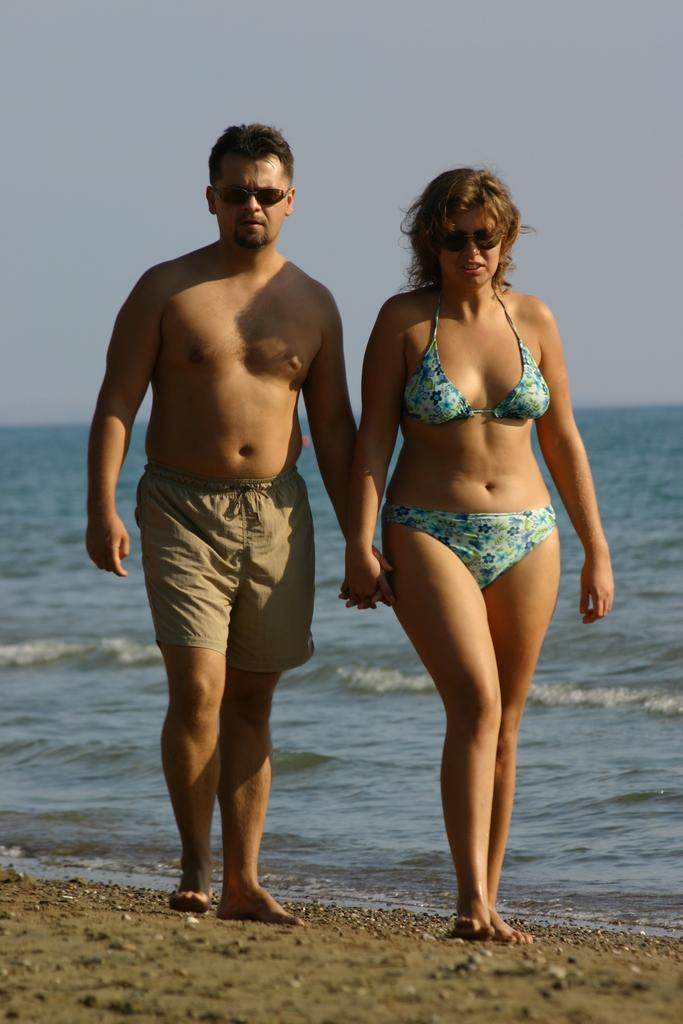Who is present in the image? There is a man and a woman in the image. What are the man and woman doing in the image? The man and woman are walking on the beach. What can be seen in the background of the image? There is water and sky visible in the background of the image. What type of wine is the man drinking in the image? There is no wine present in the image; the man and woman are walking on the beach. 